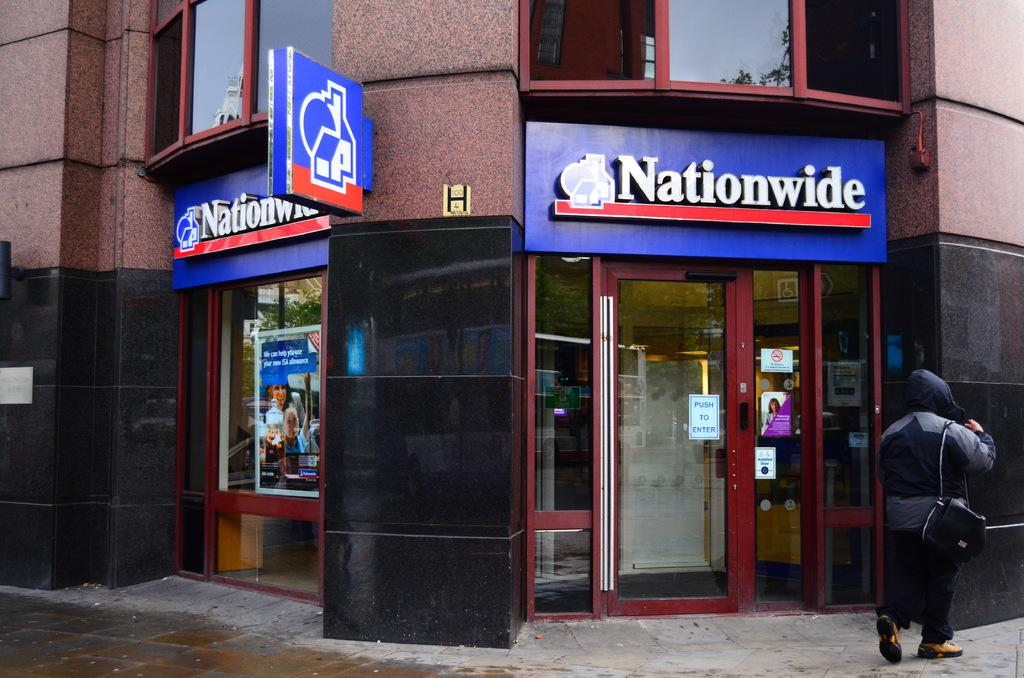What can be seen on the right side of the image? There is a person on the right side of the image. What is the person wearing? The person is wearing a black dress. What else is the person carrying? The person is carrying a black bag. What is visible in the background of the image? There is a building in the background of the image. What is special about the building's doors? The building has glass doors. What is attached to the glass doors? There are posters attached to the glass doors. Can you see a monkey sitting on the dock in the image? There is no monkey or dock present in the image. How many cherries are on the person's black dress? There are no cherries visible on the person's black dress in the image. 